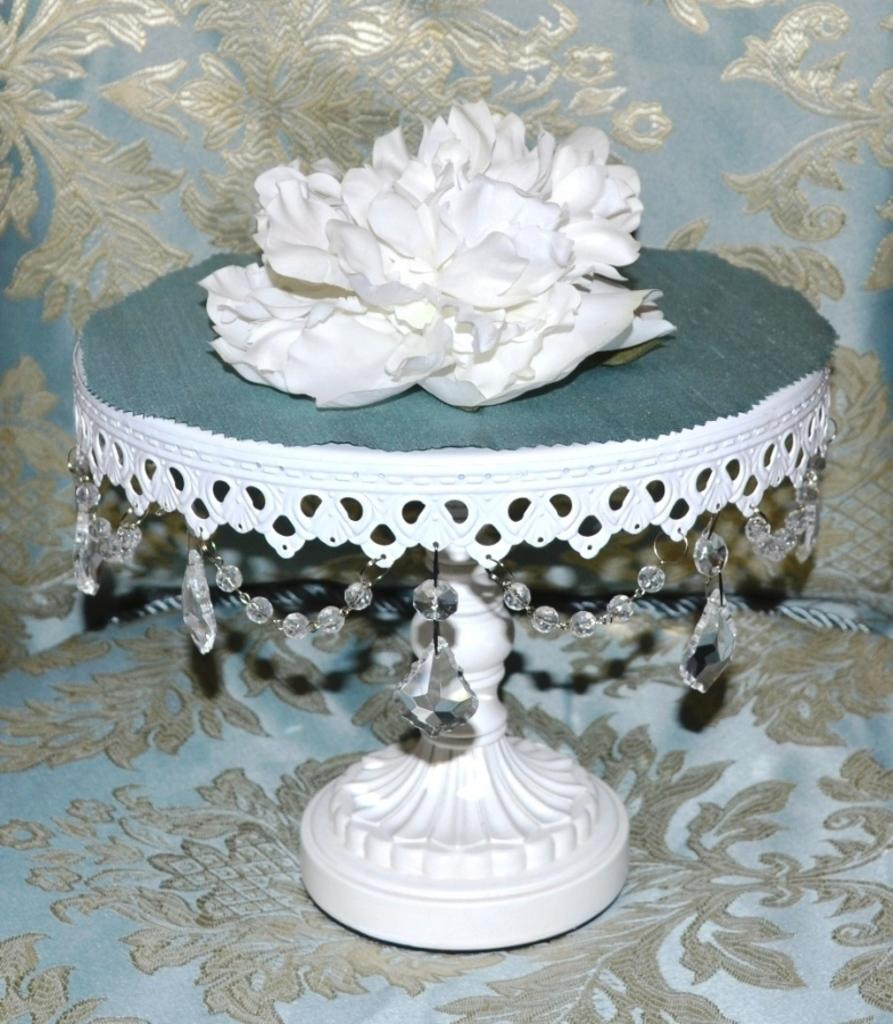What is the color of the object on the couch? The object on the couch is green and white. What colors are used for the couch? The couch is grey and blue in color. Are there any patterns or designs on the couch? Yes, there are designs on the couch. Can you see any police officers near the ocean in the image? There is no reference to police officers or the ocean in the image, so it is not possible to answer that question. 